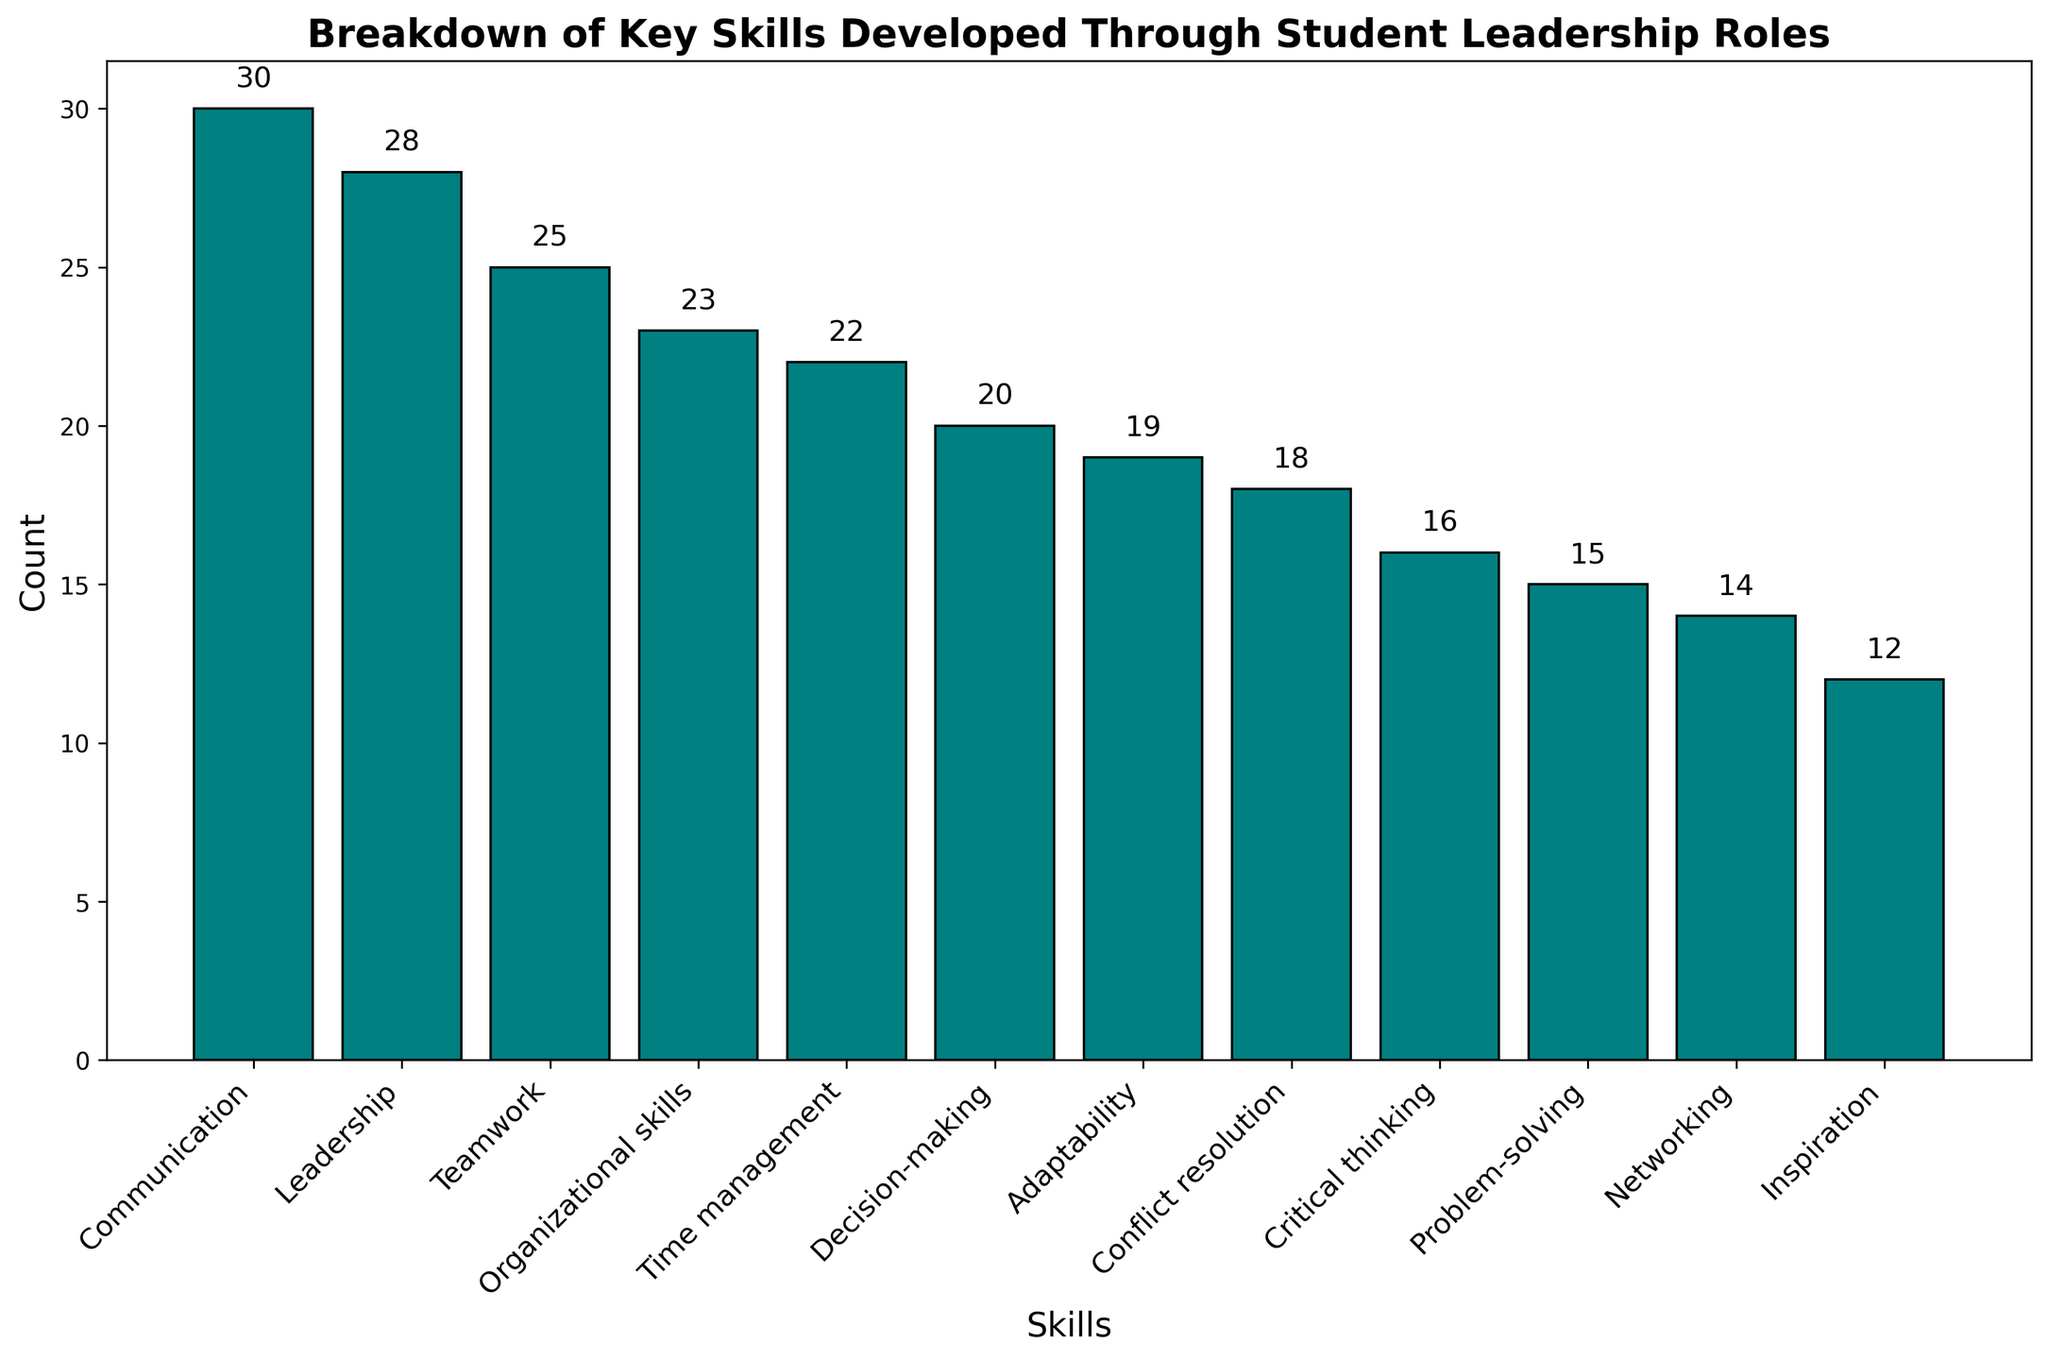What skill has the highest count? To determine this, look at the bars and find the tallest one. The skill corresponding to the tallest bar is the one with the highest count.
Answer: Communication Which two skills have the closest counts? Compare the heights of the bars to identify the two bars that are nearly equal in height. The skills corresponding to these bars have the closest counts.
Answer: Critical thinking and Problem-solving How many skills have counts greater than 20? Count the number of bars that extend above the 20-mark on the y-axis.
Answer: 6 skills What is the total count for Decision-making and Time management combined? Find the counts for Decision-making (20) and Time management (22), then add them together.
Answer: 42 Which skill has a lower count, Networking or Conflict resolution? Compare the heights of the bars for Networking and Conflict resolution. The skill with the shorter bar has the lower count.
Answer: Networking What is the difference in count between the skill with the highest count and the skill with the lowest count? Identify the highest count (Communication, 30) and the lowest count (Inspiration, 12), then subtract the lowest count from the highest count.
Answer: 18 How does Adaptability compare to Teamwork in terms of count? Compare the heights of the bars for Adaptability and Teamwork. Determine whether Adaptability's count is greater, less than, or equal to Teamwork's count.
Answer: Adaptability is less than Teamwork What is the average count of the skills listed? Add up the counts for all skills and divide by the number of skills (12). (30 + 25 + 15 + 20 + 22 + 18 + 28 + 16 + 19 + 14 + 12 + 23)/12 = 242/12 = 20.17
Answer: 20.17 Which two skills' combined count equals or comes closest to Organizational skills' count? Organizational skills has a count of 23. Find two other skills whose combined counts equal or come closest to 23 by matching pairs across the provided counts.
Answer: Adaptability and Decision-making What is the median count value for the skills? Organize the counts in ascending order and find the middle value(s). (12, 14, 15, 16, 18, 19, 20, 22, 23, 25, 28, 30). The median is the average of the 6th and 7th values (19 and 20), so (19+20)/2 = 19.5
Answer: 19.5 